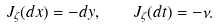<formula> <loc_0><loc_0><loc_500><loc_500>J _ { \zeta } ( d x ) = - d y , \quad J _ { \zeta } ( d t ) = - \nu .</formula> 